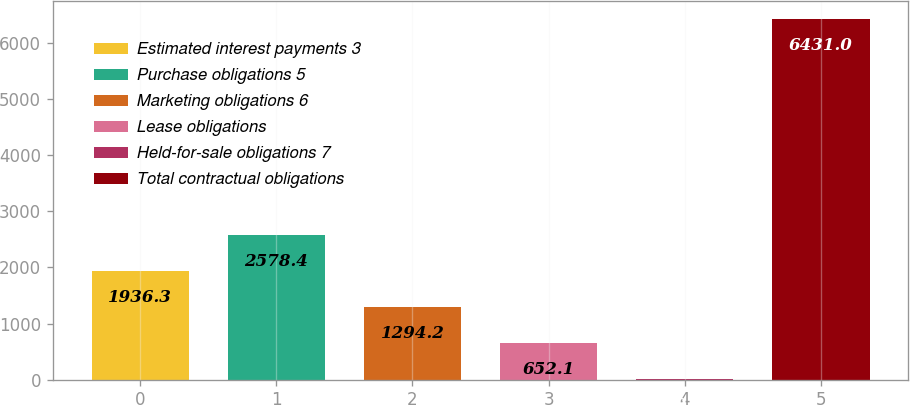Convert chart. <chart><loc_0><loc_0><loc_500><loc_500><bar_chart><fcel>Estimated interest payments 3<fcel>Purchase obligations 5<fcel>Marketing obligations 6<fcel>Lease obligations<fcel>Held-for-sale obligations 7<fcel>Total contractual obligations<nl><fcel>1936.3<fcel>2578.4<fcel>1294.2<fcel>652.1<fcel>10<fcel>6431<nl></chart> 